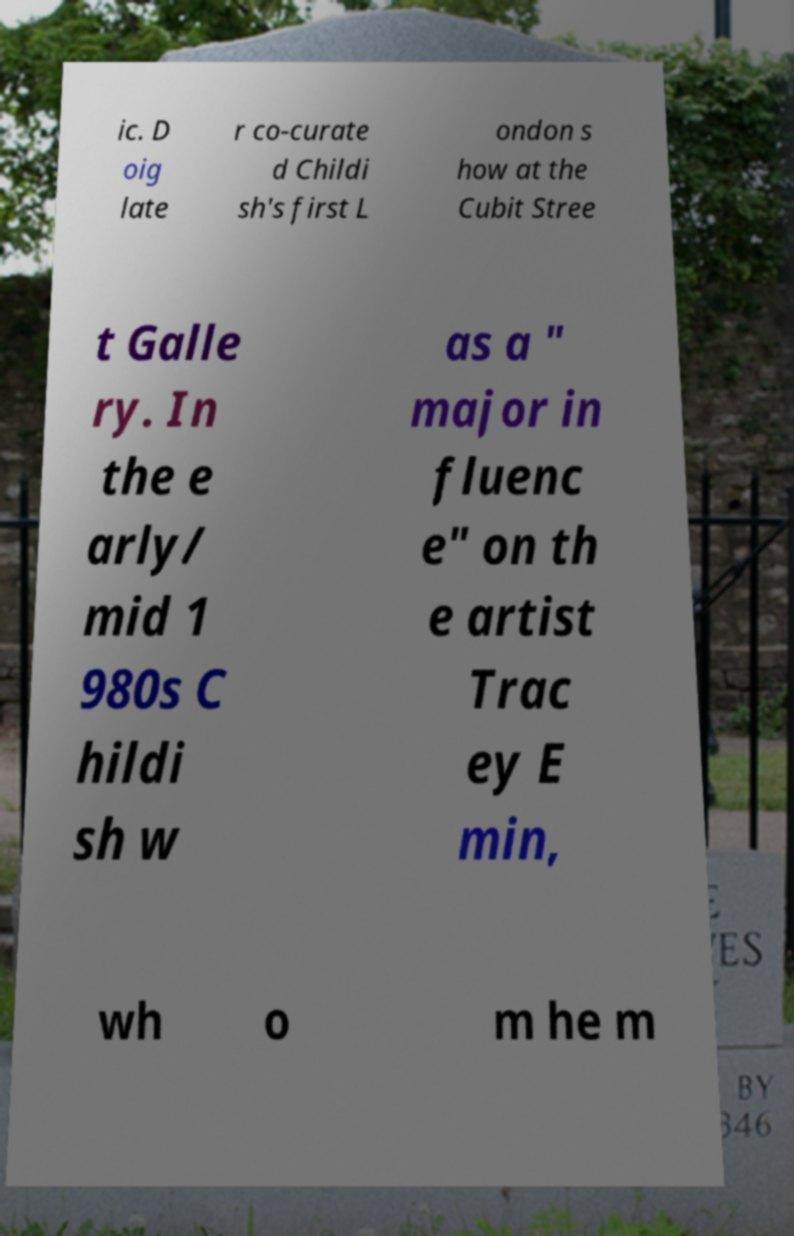Could you extract and type out the text from this image? ic. D oig late r co-curate d Childi sh's first L ondon s how at the Cubit Stree t Galle ry. In the e arly/ mid 1 980s C hildi sh w as a " major in fluenc e" on th e artist Trac ey E min, wh o m he m 